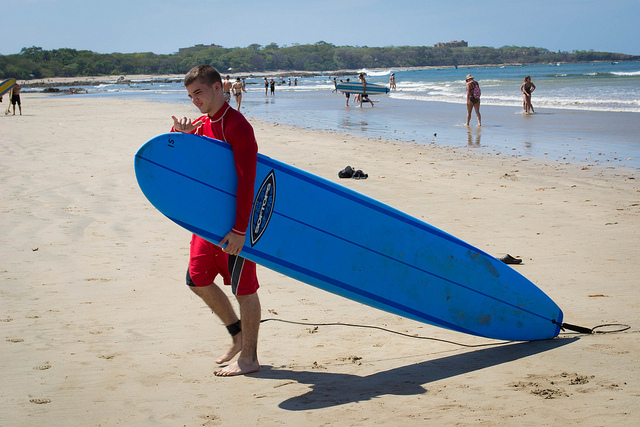Please extract the text content from this image. S 